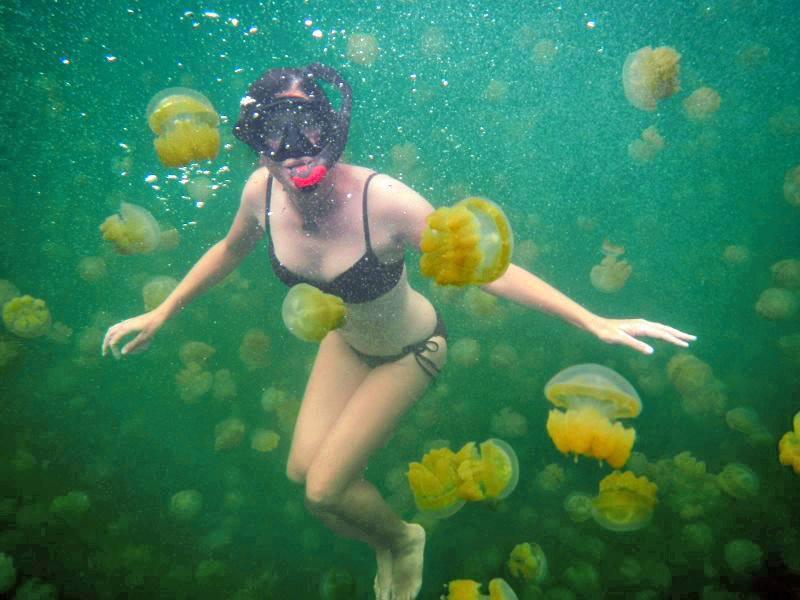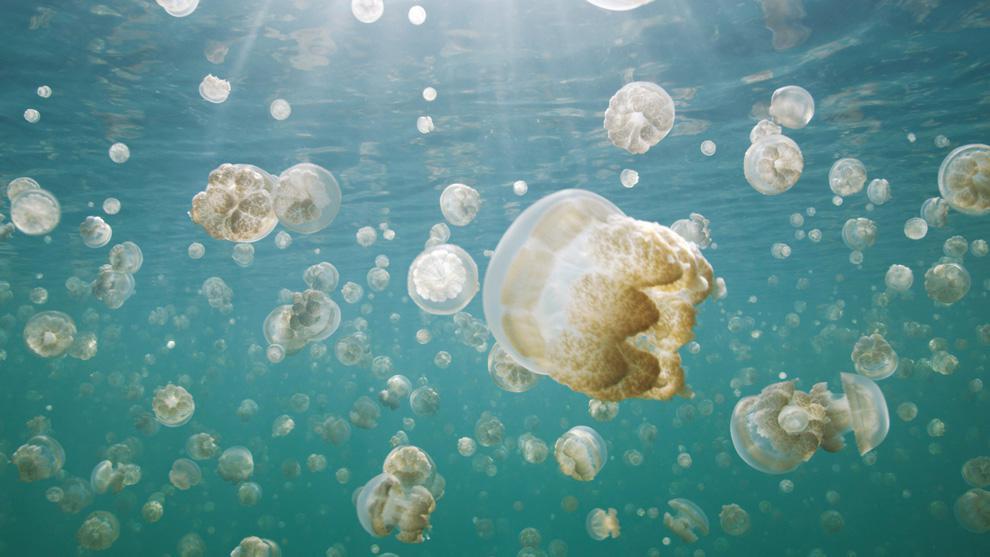The first image is the image on the left, the second image is the image on the right. Given the left and right images, does the statement "There is a single large jellyfish in the image on the right." hold true? Answer yes or no. No. 